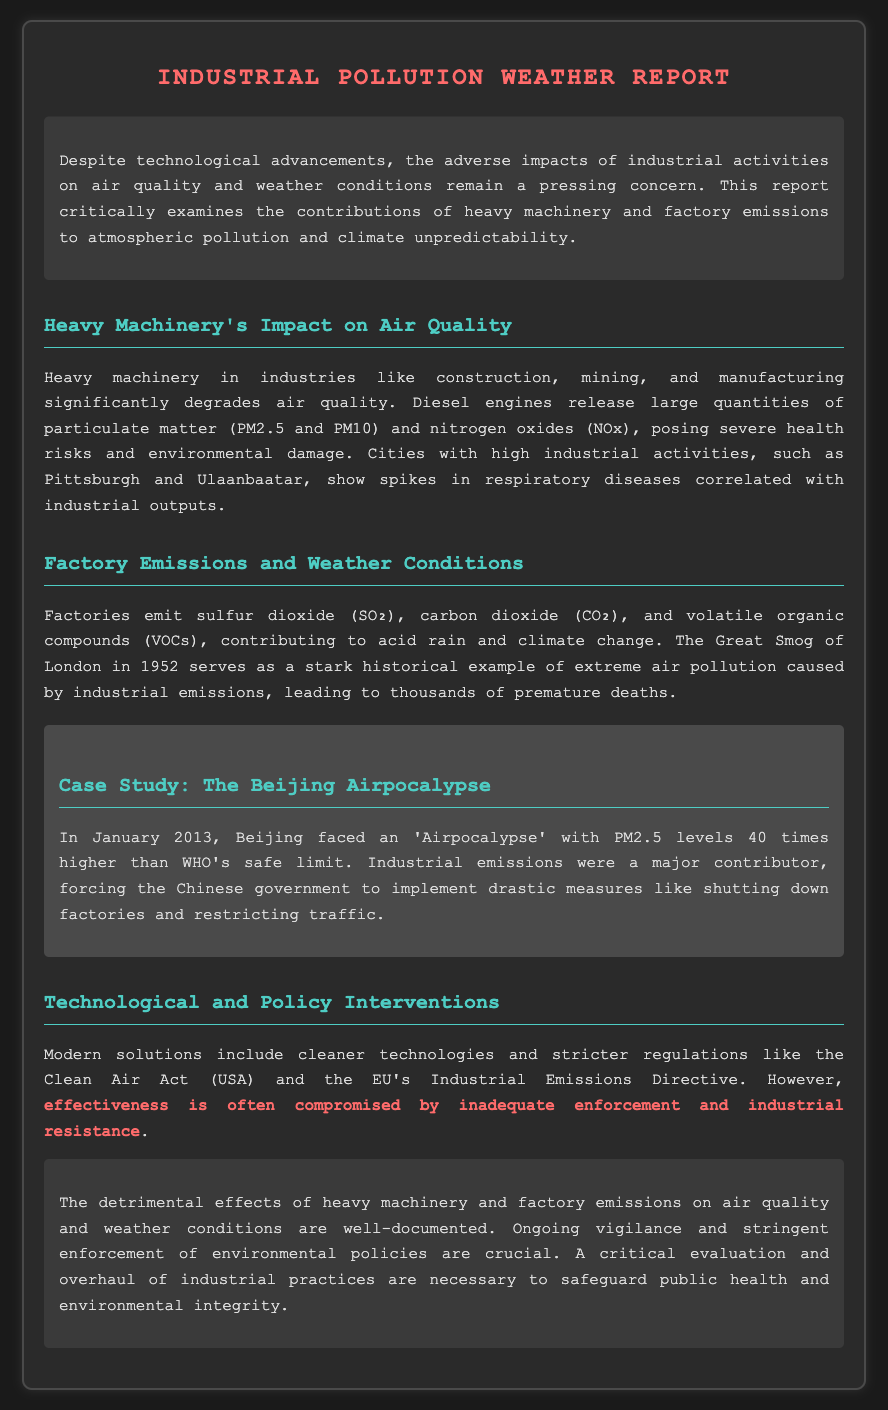What is the report about? The report critically examines the contributions of heavy machinery and factory emissions to atmospheric pollution and climate unpredictability.
Answer: Industrial pollution Which cities are mentioned in relation to respiratory diseases? The document mentions that cities with high industrial activities show spikes in respiratory diseases correlated with industrial outputs.
Answer: Pittsburgh and Ulaanbaatar What major event in 1952 is highlighted as a historical example of air pollution? The document references a significant historical event that exemplifies the consequences of extreme air pollution from industrial emissions.
Answer: The Great Smog of London During which month and year did the 'Airpocalypse' occur in Beijing? The document describes a specific event referred to as the 'Airpocalypse' and when it took place.
Answer: January 2013 What dangerous airborne particles are highlighted as being released by heavy machinery? This question seeks to identify pollutants mentioned in the document associated with heavy machinery usage.
Answer: PM2.5 and PM10 What legislation is cited regarding technological and policy interventions in air quality? The document refers to specific legislation aimed at improving air quality and limiting emissions.
Answer: Clean Air Act What is one of the major pollutants emitted by factories? The report lists a few pollutants in relation to factory emissions and their environmental effects.
Answer: Sulfur dioxide What was the PM2.5 level in Beijing during the 'Airpocalypse'? The document specifies an alarming level of PM2.5 during the event discussed.
Answer: 40 times higher than WHO's safe limit What is a common consequence mentioned resulting from factory emissions? This question targets the negative effects of emissions on both environmental conditions and public health.
Answer: Acid rain 